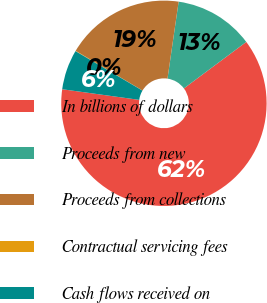Convert chart. <chart><loc_0><loc_0><loc_500><loc_500><pie_chart><fcel>In billions of dollars<fcel>Proceeds from new<fcel>Proceeds from collections<fcel>Contractual servicing fees<fcel>Cash flows received on<nl><fcel>62.37%<fcel>12.52%<fcel>18.75%<fcel>0.06%<fcel>6.29%<nl></chart> 